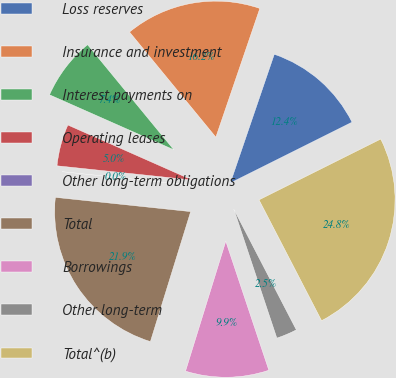Convert chart to OTSL. <chart><loc_0><loc_0><loc_500><loc_500><pie_chart><fcel>Loss reserves<fcel>Insurance and investment<fcel>Interest payments on<fcel>Operating leases<fcel>Other long-term obligations<fcel>Total<fcel>Borrowings<fcel>Other long-term<fcel>Total^(b)<nl><fcel>12.39%<fcel>16.18%<fcel>7.43%<fcel>4.96%<fcel>0.0%<fcel>21.89%<fcel>9.91%<fcel>2.48%<fcel>24.77%<nl></chart> 